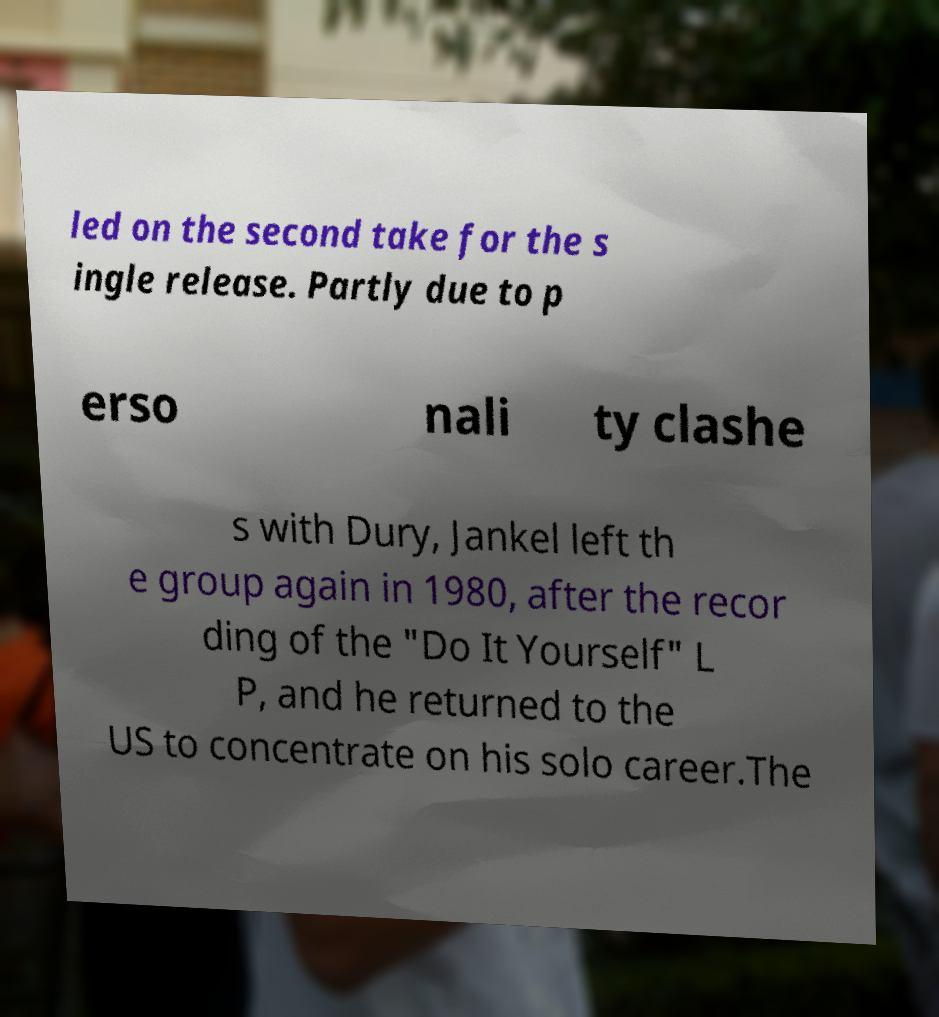There's text embedded in this image that I need extracted. Can you transcribe it verbatim? led on the second take for the s ingle release. Partly due to p erso nali ty clashe s with Dury, Jankel left th e group again in 1980, after the recor ding of the "Do It Yourself" L P, and he returned to the US to concentrate on his solo career.The 